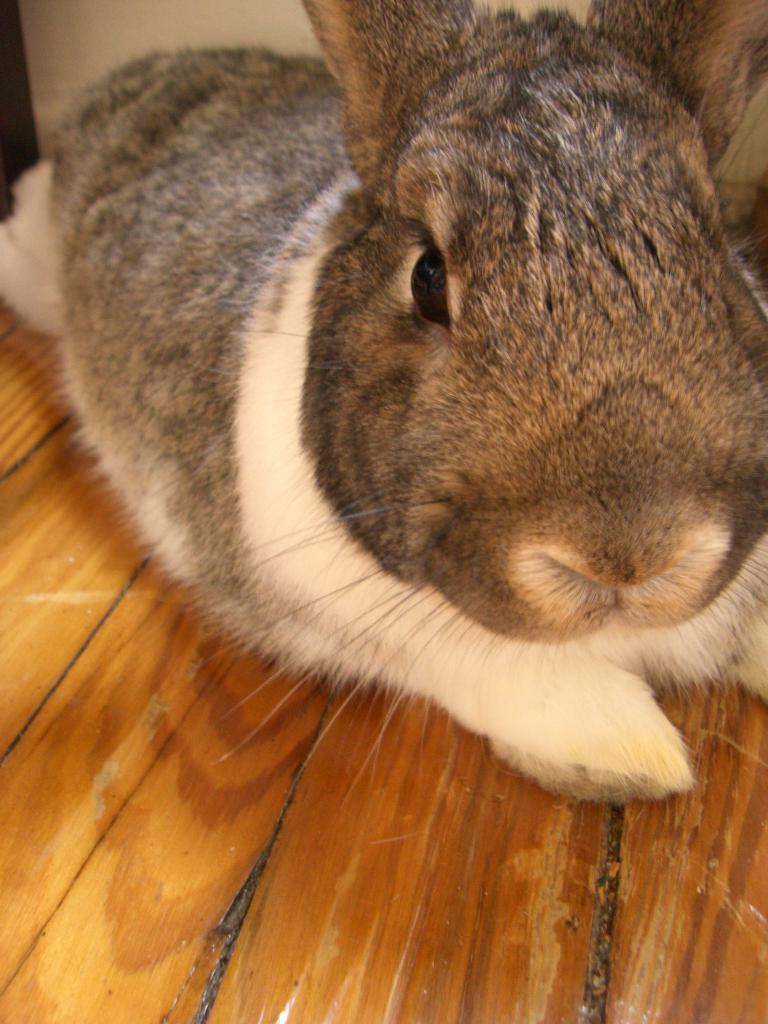What type of animal is in the image? There is a rabbit in the image. What is the rabbit sitting on? The rabbit is on a wooden object. What type of tent can be seen in the background of the image? There is no tent present in the image; it only features a rabbit on a wooden object. 